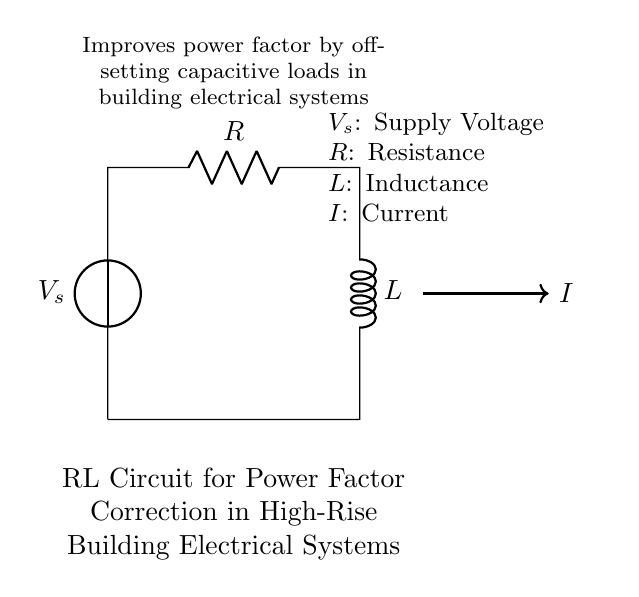What is the voltage source in this circuit? The circuit includes a voltage source labeled \(V_s\) at the left side, which supplies electrical energy to the components connected to it.
Answer: \(V_s\) What does the resistor represent in this RL circuit? The resistor labeled \(R\) is connected in series with the inductor and represents the resistance component in the circuit, which dissipates power as heat when current flows through it.
Answer: Resistance What is the role of the inductor in this circuit? The inductor labeled \(L\) is used to store energy in its magnetic field when current flows through it, helping to improve the power factor by offsetting inductive loads in the system.
Answer: Store energy How does this RL circuit improve the power factor? The RL circuit improves the power factor by offsetting the capacitive loads, which reduces the phase difference between voltage and current, making the electrical system more efficient.
Answer: Offset capacitive loads What is the relationship between current and inductance in this circuit? The current labeled \(I\) in the circuit flows through both the resistor and the inductor, and the inductor creates a back EMF that opposes changes in current, which affects the overall circuit impedance and current flow.
Answer: Opposes changes in current What are the main components of this RL circuit? The main components of this circuit are the voltage source, resistor, and inductor, which all work together to regulate current flow and improve power factor.
Answer: Voltage source, resistor, inductor What does the arrow indicate in the circuit? The arrow indicates the direction of current flow indicated as \(I\) in the circuit, showing how the electric charge moves through the components from the voltage source through the resistor and inductor.
Answer: Direction of current flow 